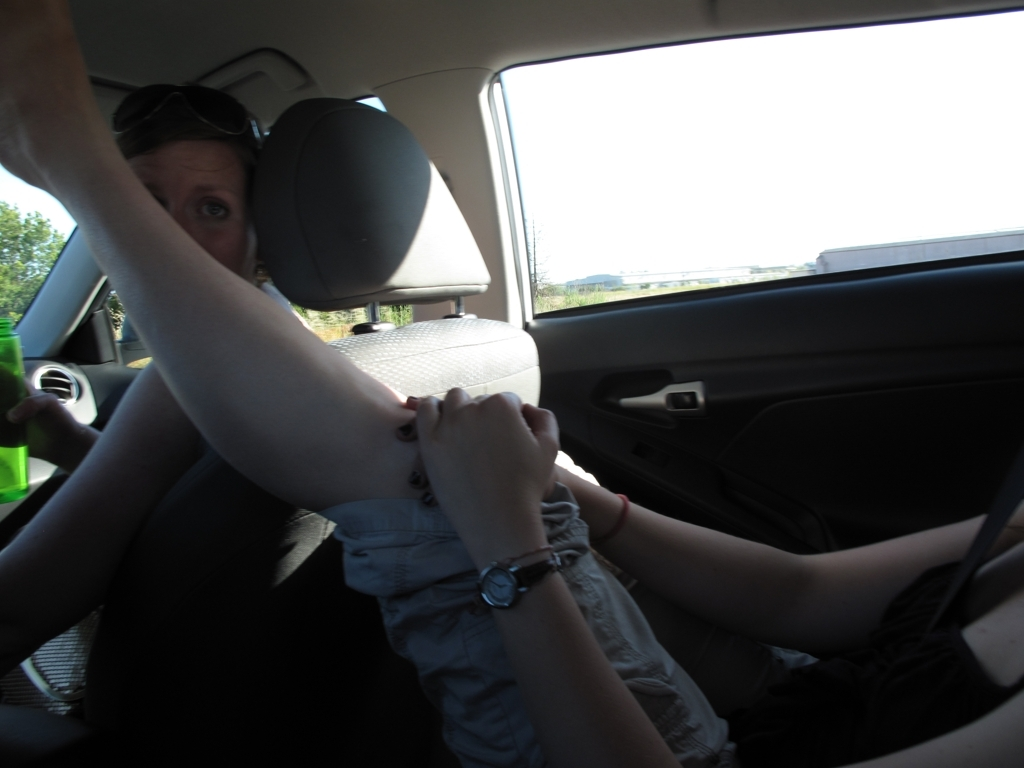Is the overall quality of this image acceptable? The quality of the image is somewhat compromised due to its underexposure and the blurred motion, which suggests that the picture was taken in a hurried or spontaneous manner, possibly from inside a moving vehicle. The framing does not conform to conventional photography standards, as the subjects are not clearly visible and the composition does not guide the viewer's attention effectively. 